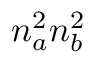Convert formula to latex. <formula><loc_0><loc_0><loc_500><loc_500>n _ { a } ^ { 2 } n _ { b } ^ { 2 }</formula> 